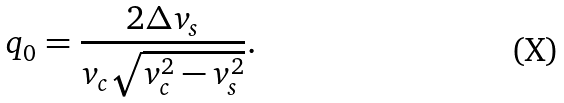<formula> <loc_0><loc_0><loc_500><loc_500>q _ { 0 } = \frac { 2 \Delta v _ { s } } { v _ { c } \sqrt { v _ { c } ^ { 2 } - v _ { s } ^ { 2 } } } .</formula> 